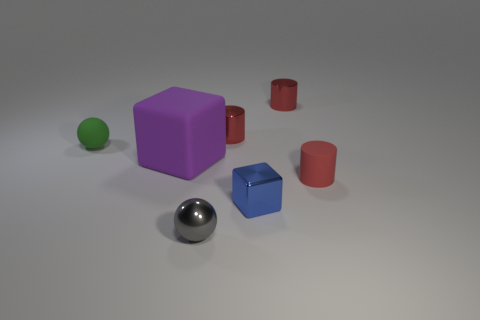Add 3 tiny gray metallic objects. How many objects exist? 10 Subtract all spheres. How many objects are left? 5 Add 4 purple matte blocks. How many purple matte blocks are left? 5 Add 6 gray spheres. How many gray spheres exist? 7 Subtract 0 green cylinders. How many objects are left? 7 Subtract all big brown metallic spheres. Subtract all small blue things. How many objects are left? 6 